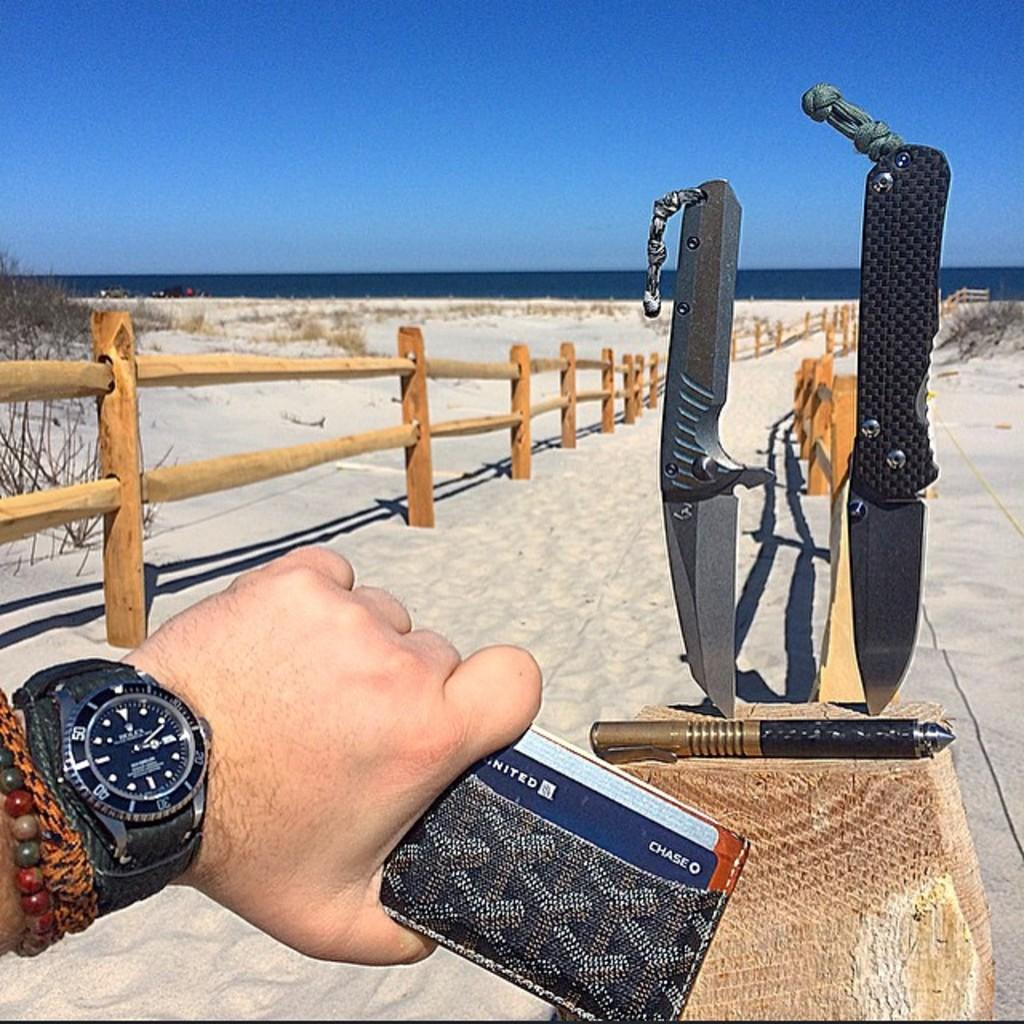<image>
Create a compact narrative representing the image presented. Man holding a wallet with a card that says Chase in it. 